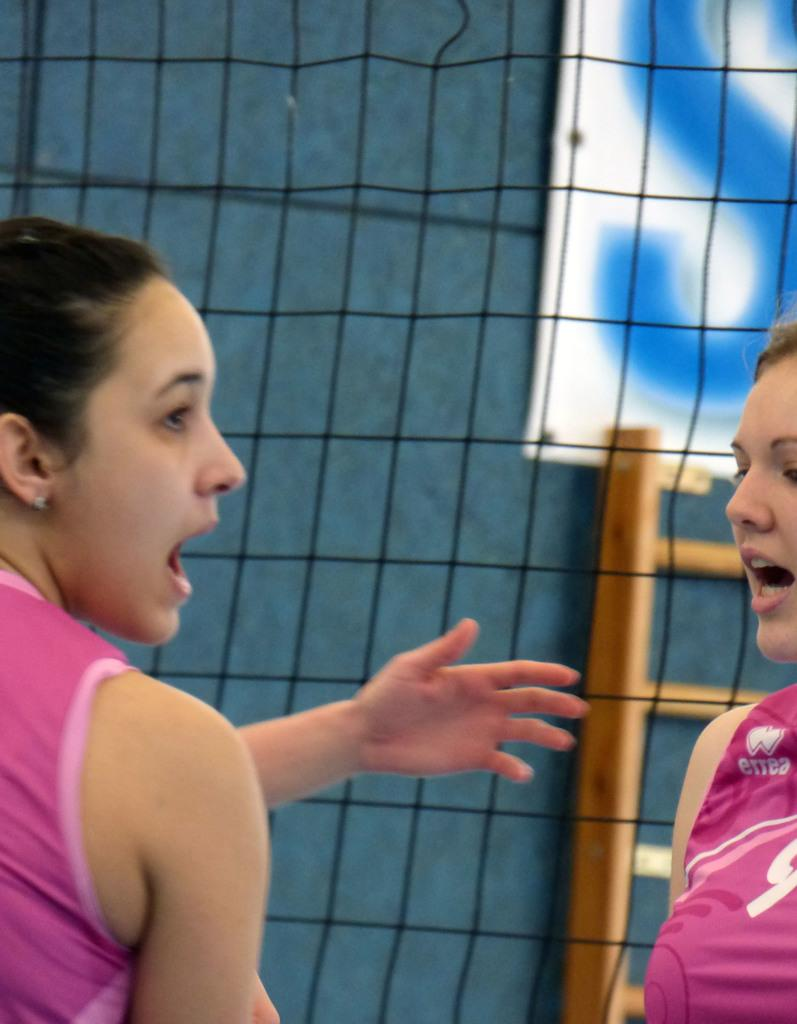How many people are in the image? There are two persons in the image. What can be seen in the background of the image? There is a sports net in the image. What other object is present in the image? There is a ladder in the image. What is located in the top right corner of the image? There appears to be a banner or a board in the top right corner of the image. What type of slave is depicted in the image? There is no depiction of a slave in the image; it features two persons and various objects. What type of basketball game is being played in the image? There is no basketball game present in the image; it features a sports net, but no basketball activity is shown. 